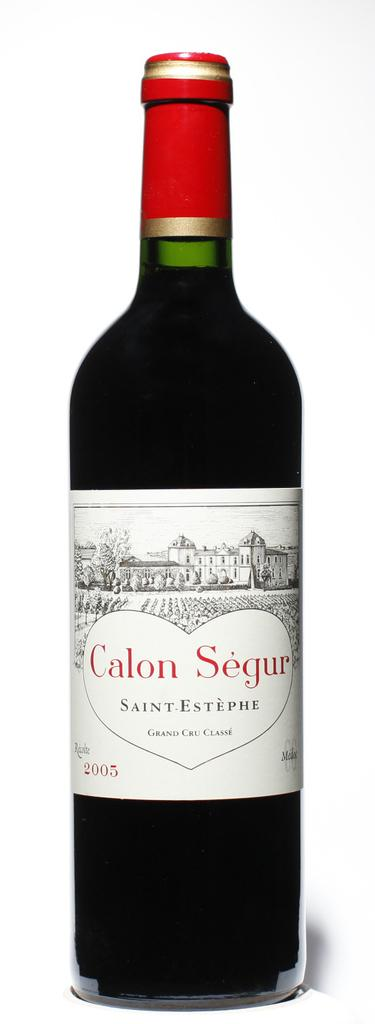<image>
Provide a brief description of the given image. A bottle of Calon Segur from 2005 has a red top. 